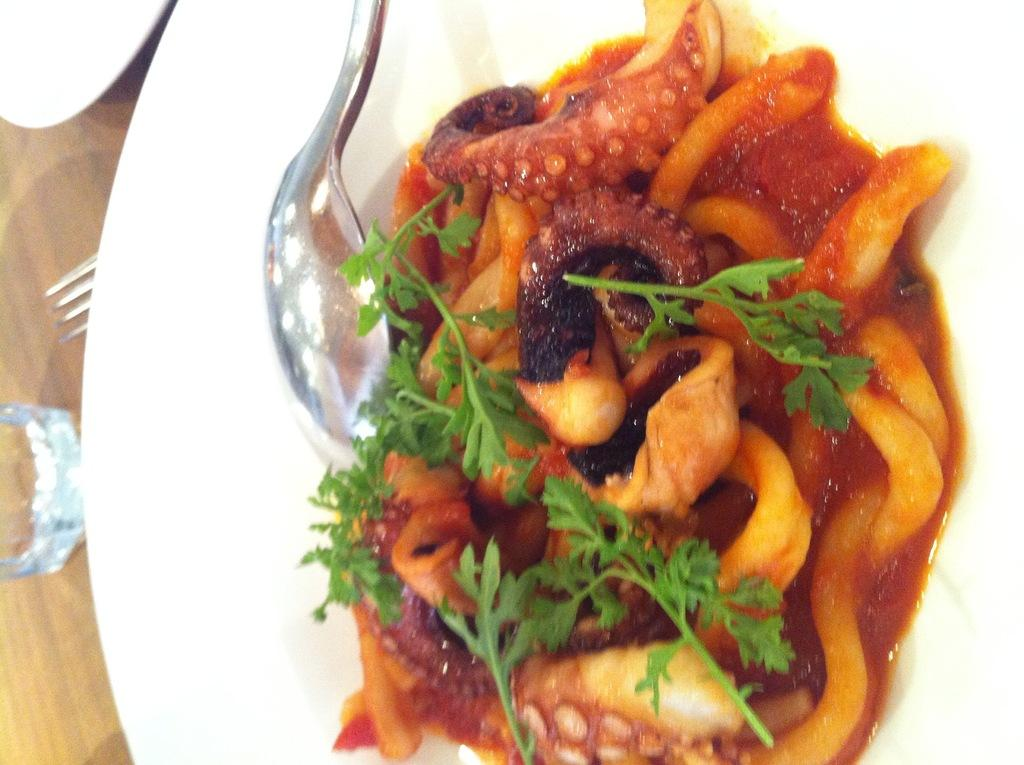What type of container is visible in the image? There is a glass in the image. What utensil can be seen in the image? There is a fork in the image. What is the plate used for in the image? The plate contains food. What other utensil is present on the plate? There is a spoon on the surface of the plate. How many women are sitting on the chairs in the image? There are no women or chairs present in the image. Is the person in the image sleeping? There is no person present in the image, so it is not possible to determine if they are sleeping. 